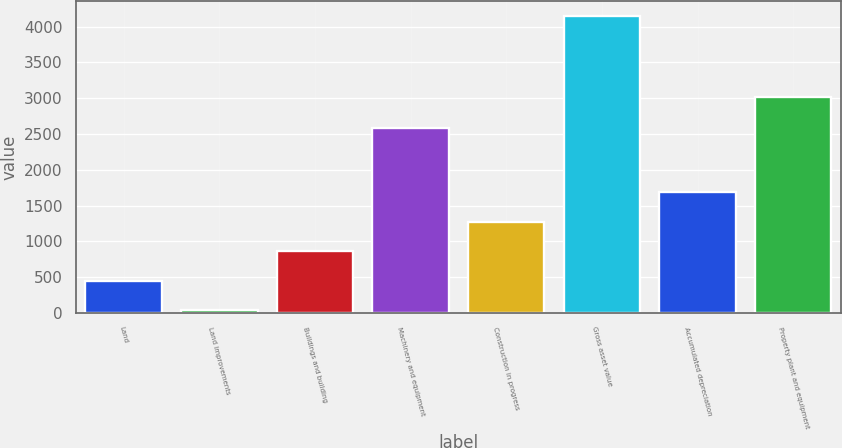Convert chart to OTSL. <chart><loc_0><loc_0><loc_500><loc_500><bar_chart><fcel>Land<fcel>Land improvements<fcel>Buildings and building<fcel>Machinery and equipment<fcel>Construction in progress<fcel>Gross asset value<fcel>Accumulated depreciation<fcel>Property plant and equipment<nl><fcel>449.9<fcel>39<fcel>860.8<fcel>2589<fcel>1271.7<fcel>4148<fcel>1682.6<fcel>3017<nl></chart> 